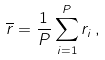<formula> <loc_0><loc_0><loc_500><loc_500>\overline { r } = \frac { 1 } { P } \sum _ { i = 1 } ^ { P } { r } _ { i } \, ,</formula> 